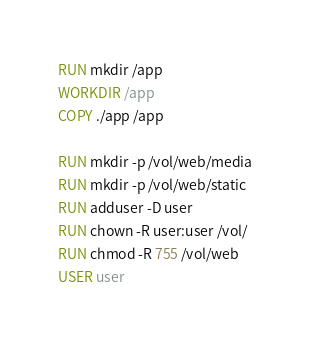<code> <loc_0><loc_0><loc_500><loc_500><_Dockerfile_>
RUN mkdir /app
WORKDIR /app
COPY ./app /app

RUN mkdir -p /vol/web/media
RUN mkdir -p /vol/web/static
RUN adduser -D user
RUN chown -R user:user /vol/
RUN chmod -R 755 /vol/web
USER user
</code> 